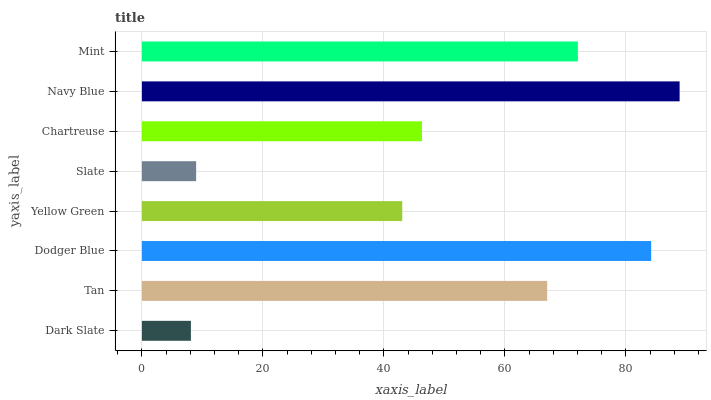Is Dark Slate the minimum?
Answer yes or no. Yes. Is Navy Blue the maximum?
Answer yes or no. Yes. Is Tan the minimum?
Answer yes or no. No. Is Tan the maximum?
Answer yes or no. No. Is Tan greater than Dark Slate?
Answer yes or no. Yes. Is Dark Slate less than Tan?
Answer yes or no. Yes. Is Dark Slate greater than Tan?
Answer yes or no. No. Is Tan less than Dark Slate?
Answer yes or no. No. Is Tan the high median?
Answer yes or no. Yes. Is Chartreuse the low median?
Answer yes or no. Yes. Is Mint the high median?
Answer yes or no. No. Is Dodger Blue the low median?
Answer yes or no. No. 